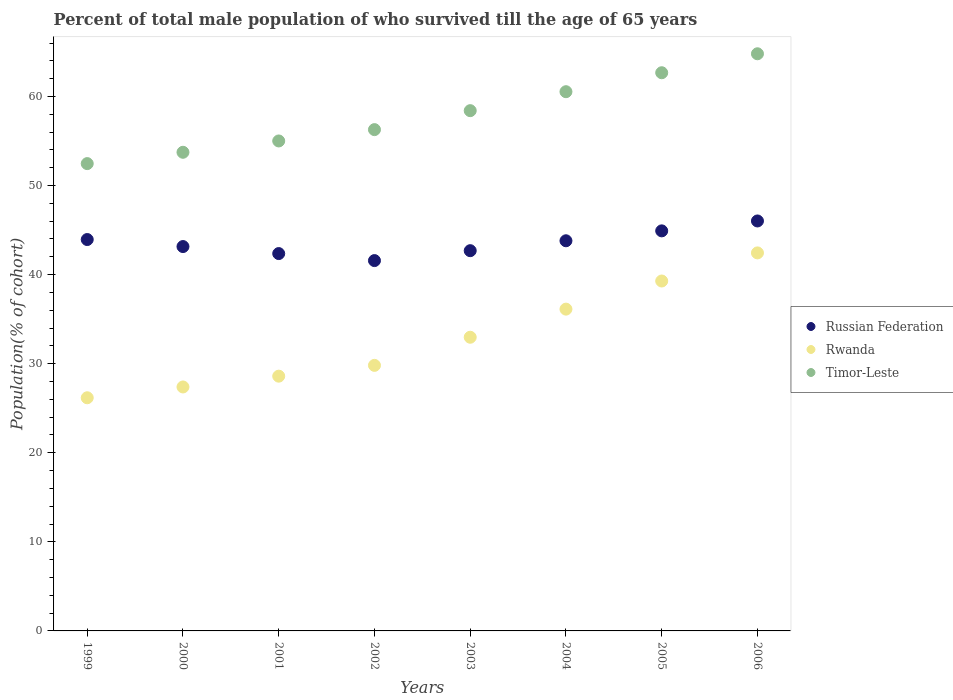What is the percentage of total male population who survived till the age of 65 years in Timor-Leste in 2003?
Your response must be concise. 58.41. Across all years, what is the maximum percentage of total male population who survived till the age of 65 years in Rwanda?
Your answer should be very brief. 42.44. Across all years, what is the minimum percentage of total male population who survived till the age of 65 years in Russian Federation?
Keep it short and to the point. 41.57. In which year was the percentage of total male population who survived till the age of 65 years in Russian Federation maximum?
Offer a terse response. 2006. What is the total percentage of total male population who survived till the age of 65 years in Rwanda in the graph?
Offer a terse response. 262.79. What is the difference between the percentage of total male population who survived till the age of 65 years in Russian Federation in 2005 and that in 2006?
Give a very brief answer. -1.11. What is the difference between the percentage of total male population who survived till the age of 65 years in Russian Federation in 2005 and the percentage of total male population who survived till the age of 65 years in Timor-Leste in 2000?
Provide a succinct answer. -8.82. What is the average percentage of total male population who survived till the age of 65 years in Russian Federation per year?
Keep it short and to the point. 43.56. In the year 2006, what is the difference between the percentage of total male population who survived till the age of 65 years in Rwanda and percentage of total male population who survived till the age of 65 years in Russian Federation?
Make the answer very short. -3.58. In how many years, is the percentage of total male population who survived till the age of 65 years in Russian Federation greater than 48 %?
Make the answer very short. 0. What is the ratio of the percentage of total male population who survived till the age of 65 years in Rwanda in 2000 to that in 2006?
Your answer should be compact. 0.65. Is the percentage of total male population who survived till the age of 65 years in Rwanda in 2000 less than that in 2004?
Your answer should be compact. Yes. What is the difference between the highest and the second highest percentage of total male population who survived till the age of 65 years in Russian Federation?
Provide a short and direct response. 1.11. What is the difference between the highest and the lowest percentage of total male population who survived till the age of 65 years in Timor-Leste?
Your response must be concise. 12.33. Is the sum of the percentage of total male population who survived till the age of 65 years in Russian Federation in 1999 and 2000 greater than the maximum percentage of total male population who survived till the age of 65 years in Rwanda across all years?
Provide a short and direct response. Yes. Is it the case that in every year, the sum of the percentage of total male population who survived till the age of 65 years in Rwanda and percentage of total male population who survived till the age of 65 years in Russian Federation  is greater than the percentage of total male population who survived till the age of 65 years in Timor-Leste?
Ensure brevity in your answer.  Yes. Does the percentage of total male population who survived till the age of 65 years in Rwanda monotonically increase over the years?
Your response must be concise. Yes. How many dotlines are there?
Provide a short and direct response. 3. How many years are there in the graph?
Provide a short and direct response. 8. What is the difference between two consecutive major ticks on the Y-axis?
Your answer should be compact. 10. Does the graph contain any zero values?
Offer a terse response. No. Does the graph contain grids?
Offer a very short reply. No. Where does the legend appear in the graph?
Ensure brevity in your answer.  Center right. How are the legend labels stacked?
Make the answer very short. Vertical. What is the title of the graph?
Make the answer very short. Percent of total male population of who survived till the age of 65 years. What is the label or title of the Y-axis?
Give a very brief answer. Population(% of cohort). What is the Population(% of cohort) of Russian Federation in 1999?
Your answer should be very brief. 43.94. What is the Population(% of cohort) of Rwanda in 1999?
Offer a terse response. 26.17. What is the Population(% of cohort) in Timor-Leste in 1999?
Your response must be concise. 52.46. What is the Population(% of cohort) in Russian Federation in 2000?
Provide a succinct answer. 43.15. What is the Population(% of cohort) in Rwanda in 2000?
Your response must be concise. 27.39. What is the Population(% of cohort) of Timor-Leste in 2000?
Ensure brevity in your answer.  53.73. What is the Population(% of cohort) of Russian Federation in 2001?
Provide a short and direct response. 42.36. What is the Population(% of cohort) in Rwanda in 2001?
Provide a succinct answer. 28.6. What is the Population(% of cohort) in Timor-Leste in 2001?
Make the answer very short. 55.01. What is the Population(% of cohort) of Russian Federation in 2002?
Your response must be concise. 41.57. What is the Population(% of cohort) in Rwanda in 2002?
Keep it short and to the point. 29.81. What is the Population(% of cohort) in Timor-Leste in 2002?
Keep it short and to the point. 56.28. What is the Population(% of cohort) of Russian Federation in 2003?
Your response must be concise. 42.69. What is the Population(% of cohort) in Rwanda in 2003?
Your response must be concise. 32.97. What is the Population(% of cohort) in Timor-Leste in 2003?
Your response must be concise. 58.41. What is the Population(% of cohort) of Russian Federation in 2004?
Offer a terse response. 43.8. What is the Population(% of cohort) of Rwanda in 2004?
Your answer should be very brief. 36.13. What is the Population(% of cohort) of Timor-Leste in 2004?
Your answer should be very brief. 60.53. What is the Population(% of cohort) of Russian Federation in 2005?
Offer a very short reply. 44.91. What is the Population(% of cohort) of Rwanda in 2005?
Provide a short and direct response. 39.28. What is the Population(% of cohort) of Timor-Leste in 2005?
Ensure brevity in your answer.  62.66. What is the Population(% of cohort) of Russian Federation in 2006?
Offer a very short reply. 46.02. What is the Population(% of cohort) in Rwanda in 2006?
Your answer should be very brief. 42.44. What is the Population(% of cohort) in Timor-Leste in 2006?
Provide a short and direct response. 64.79. Across all years, what is the maximum Population(% of cohort) in Russian Federation?
Ensure brevity in your answer.  46.02. Across all years, what is the maximum Population(% of cohort) in Rwanda?
Make the answer very short. 42.44. Across all years, what is the maximum Population(% of cohort) of Timor-Leste?
Your answer should be very brief. 64.79. Across all years, what is the minimum Population(% of cohort) of Russian Federation?
Your answer should be compact. 41.57. Across all years, what is the minimum Population(% of cohort) in Rwanda?
Your answer should be compact. 26.17. Across all years, what is the minimum Population(% of cohort) of Timor-Leste?
Provide a short and direct response. 52.46. What is the total Population(% of cohort) in Russian Federation in the graph?
Your response must be concise. 348.45. What is the total Population(% of cohort) in Rwanda in the graph?
Make the answer very short. 262.79. What is the total Population(% of cohort) in Timor-Leste in the graph?
Your response must be concise. 463.87. What is the difference between the Population(% of cohort) in Russian Federation in 1999 and that in 2000?
Offer a very short reply. 0.79. What is the difference between the Population(% of cohort) in Rwanda in 1999 and that in 2000?
Make the answer very short. -1.21. What is the difference between the Population(% of cohort) in Timor-Leste in 1999 and that in 2000?
Your response must be concise. -1.27. What is the difference between the Population(% of cohort) in Russian Federation in 1999 and that in 2001?
Make the answer very short. 1.58. What is the difference between the Population(% of cohort) of Rwanda in 1999 and that in 2001?
Your answer should be compact. -2.42. What is the difference between the Population(% of cohort) of Timor-Leste in 1999 and that in 2001?
Make the answer very short. -2.54. What is the difference between the Population(% of cohort) in Russian Federation in 1999 and that in 2002?
Your response must be concise. 2.36. What is the difference between the Population(% of cohort) in Rwanda in 1999 and that in 2002?
Offer a very short reply. -3.64. What is the difference between the Population(% of cohort) of Timor-Leste in 1999 and that in 2002?
Offer a very short reply. -3.81. What is the difference between the Population(% of cohort) of Russian Federation in 1999 and that in 2003?
Your answer should be very brief. 1.25. What is the difference between the Population(% of cohort) in Rwanda in 1999 and that in 2003?
Provide a short and direct response. -6.79. What is the difference between the Population(% of cohort) of Timor-Leste in 1999 and that in 2003?
Your response must be concise. -5.94. What is the difference between the Population(% of cohort) in Russian Federation in 1999 and that in 2004?
Give a very brief answer. 0.14. What is the difference between the Population(% of cohort) of Rwanda in 1999 and that in 2004?
Your response must be concise. -9.95. What is the difference between the Population(% of cohort) in Timor-Leste in 1999 and that in 2004?
Make the answer very short. -8.07. What is the difference between the Population(% of cohort) of Russian Federation in 1999 and that in 2005?
Keep it short and to the point. -0.97. What is the difference between the Population(% of cohort) in Rwanda in 1999 and that in 2005?
Your answer should be very brief. -13.11. What is the difference between the Population(% of cohort) in Timor-Leste in 1999 and that in 2005?
Offer a terse response. -10.2. What is the difference between the Population(% of cohort) of Russian Federation in 1999 and that in 2006?
Provide a succinct answer. -2.09. What is the difference between the Population(% of cohort) in Rwanda in 1999 and that in 2006?
Give a very brief answer. -16.26. What is the difference between the Population(% of cohort) in Timor-Leste in 1999 and that in 2006?
Offer a terse response. -12.33. What is the difference between the Population(% of cohort) in Russian Federation in 2000 and that in 2001?
Make the answer very short. 0.79. What is the difference between the Population(% of cohort) in Rwanda in 2000 and that in 2001?
Give a very brief answer. -1.21. What is the difference between the Population(% of cohort) in Timor-Leste in 2000 and that in 2001?
Keep it short and to the point. -1.27. What is the difference between the Population(% of cohort) in Russian Federation in 2000 and that in 2002?
Provide a succinct answer. 1.58. What is the difference between the Population(% of cohort) in Rwanda in 2000 and that in 2002?
Your response must be concise. -2.42. What is the difference between the Population(% of cohort) of Timor-Leste in 2000 and that in 2002?
Provide a succinct answer. -2.54. What is the difference between the Population(% of cohort) in Russian Federation in 2000 and that in 2003?
Offer a terse response. 0.46. What is the difference between the Population(% of cohort) of Rwanda in 2000 and that in 2003?
Make the answer very short. -5.58. What is the difference between the Population(% of cohort) of Timor-Leste in 2000 and that in 2003?
Ensure brevity in your answer.  -4.67. What is the difference between the Population(% of cohort) in Russian Federation in 2000 and that in 2004?
Make the answer very short. -0.65. What is the difference between the Population(% of cohort) in Rwanda in 2000 and that in 2004?
Make the answer very short. -8.74. What is the difference between the Population(% of cohort) of Timor-Leste in 2000 and that in 2004?
Your answer should be compact. -6.8. What is the difference between the Population(% of cohort) in Russian Federation in 2000 and that in 2005?
Provide a short and direct response. -1.76. What is the difference between the Population(% of cohort) in Rwanda in 2000 and that in 2005?
Your response must be concise. -11.9. What is the difference between the Population(% of cohort) in Timor-Leste in 2000 and that in 2005?
Give a very brief answer. -8.93. What is the difference between the Population(% of cohort) of Russian Federation in 2000 and that in 2006?
Offer a terse response. -2.87. What is the difference between the Population(% of cohort) of Rwanda in 2000 and that in 2006?
Your answer should be very brief. -15.05. What is the difference between the Population(% of cohort) of Timor-Leste in 2000 and that in 2006?
Give a very brief answer. -11.06. What is the difference between the Population(% of cohort) in Russian Federation in 2001 and that in 2002?
Provide a short and direct response. 0.79. What is the difference between the Population(% of cohort) in Rwanda in 2001 and that in 2002?
Your answer should be compact. -1.21. What is the difference between the Population(% of cohort) of Timor-Leste in 2001 and that in 2002?
Offer a terse response. -1.27. What is the difference between the Population(% of cohort) in Russian Federation in 2001 and that in 2003?
Provide a succinct answer. -0.32. What is the difference between the Population(% of cohort) in Rwanda in 2001 and that in 2003?
Provide a succinct answer. -4.37. What is the difference between the Population(% of cohort) of Timor-Leste in 2001 and that in 2003?
Give a very brief answer. -3.4. What is the difference between the Population(% of cohort) in Russian Federation in 2001 and that in 2004?
Your answer should be very brief. -1.44. What is the difference between the Population(% of cohort) in Rwanda in 2001 and that in 2004?
Provide a succinct answer. -7.53. What is the difference between the Population(% of cohort) in Timor-Leste in 2001 and that in 2004?
Your answer should be compact. -5.53. What is the difference between the Population(% of cohort) in Russian Federation in 2001 and that in 2005?
Keep it short and to the point. -2.55. What is the difference between the Population(% of cohort) in Rwanda in 2001 and that in 2005?
Make the answer very short. -10.68. What is the difference between the Population(% of cohort) of Timor-Leste in 2001 and that in 2005?
Ensure brevity in your answer.  -7.66. What is the difference between the Population(% of cohort) in Russian Federation in 2001 and that in 2006?
Give a very brief answer. -3.66. What is the difference between the Population(% of cohort) of Rwanda in 2001 and that in 2006?
Offer a very short reply. -13.84. What is the difference between the Population(% of cohort) of Timor-Leste in 2001 and that in 2006?
Give a very brief answer. -9.79. What is the difference between the Population(% of cohort) of Russian Federation in 2002 and that in 2003?
Ensure brevity in your answer.  -1.11. What is the difference between the Population(% of cohort) of Rwanda in 2002 and that in 2003?
Your answer should be very brief. -3.16. What is the difference between the Population(% of cohort) in Timor-Leste in 2002 and that in 2003?
Your response must be concise. -2.13. What is the difference between the Population(% of cohort) in Russian Federation in 2002 and that in 2004?
Give a very brief answer. -2.22. What is the difference between the Population(% of cohort) in Rwanda in 2002 and that in 2004?
Your answer should be very brief. -6.31. What is the difference between the Population(% of cohort) in Timor-Leste in 2002 and that in 2004?
Give a very brief answer. -4.26. What is the difference between the Population(% of cohort) of Russian Federation in 2002 and that in 2005?
Keep it short and to the point. -3.34. What is the difference between the Population(% of cohort) in Rwanda in 2002 and that in 2005?
Provide a succinct answer. -9.47. What is the difference between the Population(% of cohort) of Timor-Leste in 2002 and that in 2005?
Provide a short and direct response. -6.39. What is the difference between the Population(% of cohort) of Russian Federation in 2002 and that in 2006?
Your answer should be very brief. -4.45. What is the difference between the Population(% of cohort) in Rwanda in 2002 and that in 2006?
Keep it short and to the point. -12.63. What is the difference between the Population(% of cohort) of Timor-Leste in 2002 and that in 2006?
Ensure brevity in your answer.  -8.52. What is the difference between the Population(% of cohort) in Russian Federation in 2003 and that in 2004?
Your answer should be very brief. -1.11. What is the difference between the Population(% of cohort) in Rwanda in 2003 and that in 2004?
Offer a terse response. -3.16. What is the difference between the Population(% of cohort) in Timor-Leste in 2003 and that in 2004?
Give a very brief answer. -2.13. What is the difference between the Population(% of cohort) in Russian Federation in 2003 and that in 2005?
Your answer should be very brief. -2.22. What is the difference between the Population(% of cohort) in Rwanda in 2003 and that in 2005?
Provide a short and direct response. -6.31. What is the difference between the Population(% of cohort) in Timor-Leste in 2003 and that in 2005?
Your answer should be very brief. -4.26. What is the difference between the Population(% of cohort) of Russian Federation in 2003 and that in 2006?
Your answer should be very brief. -3.34. What is the difference between the Population(% of cohort) of Rwanda in 2003 and that in 2006?
Make the answer very short. -9.47. What is the difference between the Population(% of cohort) of Timor-Leste in 2003 and that in 2006?
Your answer should be compact. -6.39. What is the difference between the Population(% of cohort) of Russian Federation in 2004 and that in 2005?
Provide a short and direct response. -1.11. What is the difference between the Population(% of cohort) of Rwanda in 2004 and that in 2005?
Give a very brief answer. -3.16. What is the difference between the Population(% of cohort) of Timor-Leste in 2004 and that in 2005?
Your answer should be compact. -2.13. What is the difference between the Population(% of cohort) of Russian Federation in 2004 and that in 2006?
Your response must be concise. -2.22. What is the difference between the Population(% of cohort) of Rwanda in 2004 and that in 2006?
Your response must be concise. -6.31. What is the difference between the Population(% of cohort) of Timor-Leste in 2004 and that in 2006?
Provide a short and direct response. -4.26. What is the difference between the Population(% of cohort) in Russian Federation in 2005 and that in 2006?
Keep it short and to the point. -1.11. What is the difference between the Population(% of cohort) of Rwanda in 2005 and that in 2006?
Ensure brevity in your answer.  -3.16. What is the difference between the Population(% of cohort) of Timor-Leste in 2005 and that in 2006?
Offer a terse response. -2.13. What is the difference between the Population(% of cohort) of Russian Federation in 1999 and the Population(% of cohort) of Rwanda in 2000?
Provide a short and direct response. 16.55. What is the difference between the Population(% of cohort) of Russian Federation in 1999 and the Population(% of cohort) of Timor-Leste in 2000?
Your answer should be very brief. -9.8. What is the difference between the Population(% of cohort) of Rwanda in 1999 and the Population(% of cohort) of Timor-Leste in 2000?
Keep it short and to the point. -27.56. What is the difference between the Population(% of cohort) of Russian Federation in 1999 and the Population(% of cohort) of Rwanda in 2001?
Keep it short and to the point. 15.34. What is the difference between the Population(% of cohort) of Russian Federation in 1999 and the Population(% of cohort) of Timor-Leste in 2001?
Your answer should be compact. -11.07. What is the difference between the Population(% of cohort) of Rwanda in 1999 and the Population(% of cohort) of Timor-Leste in 2001?
Your answer should be compact. -28.83. What is the difference between the Population(% of cohort) of Russian Federation in 1999 and the Population(% of cohort) of Rwanda in 2002?
Your answer should be compact. 14.13. What is the difference between the Population(% of cohort) of Russian Federation in 1999 and the Population(% of cohort) of Timor-Leste in 2002?
Provide a short and direct response. -12.34. What is the difference between the Population(% of cohort) of Rwanda in 1999 and the Population(% of cohort) of Timor-Leste in 2002?
Offer a very short reply. -30.1. What is the difference between the Population(% of cohort) in Russian Federation in 1999 and the Population(% of cohort) in Rwanda in 2003?
Your answer should be very brief. 10.97. What is the difference between the Population(% of cohort) in Russian Federation in 1999 and the Population(% of cohort) in Timor-Leste in 2003?
Provide a short and direct response. -14.47. What is the difference between the Population(% of cohort) of Rwanda in 1999 and the Population(% of cohort) of Timor-Leste in 2003?
Offer a terse response. -32.23. What is the difference between the Population(% of cohort) in Russian Federation in 1999 and the Population(% of cohort) in Rwanda in 2004?
Make the answer very short. 7.81. What is the difference between the Population(% of cohort) of Russian Federation in 1999 and the Population(% of cohort) of Timor-Leste in 2004?
Your answer should be compact. -16.6. What is the difference between the Population(% of cohort) of Rwanda in 1999 and the Population(% of cohort) of Timor-Leste in 2004?
Offer a terse response. -34.36. What is the difference between the Population(% of cohort) in Russian Federation in 1999 and the Population(% of cohort) in Rwanda in 2005?
Provide a short and direct response. 4.66. What is the difference between the Population(% of cohort) in Russian Federation in 1999 and the Population(% of cohort) in Timor-Leste in 2005?
Offer a very short reply. -18.73. What is the difference between the Population(% of cohort) of Rwanda in 1999 and the Population(% of cohort) of Timor-Leste in 2005?
Ensure brevity in your answer.  -36.49. What is the difference between the Population(% of cohort) in Russian Federation in 1999 and the Population(% of cohort) in Rwanda in 2006?
Make the answer very short. 1.5. What is the difference between the Population(% of cohort) of Russian Federation in 1999 and the Population(% of cohort) of Timor-Leste in 2006?
Offer a very short reply. -20.85. What is the difference between the Population(% of cohort) in Rwanda in 1999 and the Population(% of cohort) in Timor-Leste in 2006?
Provide a short and direct response. -38.62. What is the difference between the Population(% of cohort) in Russian Federation in 2000 and the Population(% of cohort) in Rwanda in 2001?
Offer a terse response. 14.55. What is the difference between the Population(% of cohort) in Russian Federation in 2000 and the Population(% of cohort) in Timor-Leste in 2001?
Give a very brief answer. -11.86. What is the difference between the Population(% of cohort) of Rwanda in 2000 and the Population(% of cohort) of Timor-Leste in 2001?
Your answer should be very brief. -27.62. What is the difference between the Population(% of cohort) in Russian Federation in 2000 and the Population(% of cohort) in Rwanda in 2002?
Provide a succinct answer. 13.34. What is the difference between the Population(% of cohort) in Russian Federation in 2000 and the Population(% of cohort) in Timor-Leste in 2002?
Your response must be concise. -13.13. What is the difference between the Population(% of cohort) in Rwanda in 2000 and the Population(% of cohort) in Timor-Leste in 2002?
Provide a short and direct response. -28.89. What is the difference between the Population(% of cohort) of Russian Federation in 2000 and the Population(% of cohort) of Rwanda in 2003?
Keep it short and to the point. 10.18. What is the difference between the Population(% of cohort) in Russian Federation in 2000 and the Population(% of cohort) in Timor-Leste in 2003?
Your answer should be compact. -15.26. What is the difference between the Population(% of cohort) in Rwanda in 2000 and the Population(% of cohort) in Timor-Leste in 2003?
Your answer should be very brief. -31.02. What is the difference between the Population(% of cohort) in Russian Federation in 2000 and the Population(% of cohort) in Rwanda in 2004?
Give a very brief answer. 7.02. What is the difference between the Population(% of cohort) of Russian Federation in 2000 and the Population(% of cohort) of Timor-Leste in 2004?
Your answer should be very brief. -17.38. What is the difference between the Population(% of cohort) of Rwanda in 2000 and the Population(% of cohort) of Timor-Leste in 2004?
Offer a terse response. -33.15. What is the difference between the Population(% of cohort) in Russian Federation in 2000 and the Population(% of cohort) in Rwanda in 2005?
Make the answer very short. 3.87. What is the difference between the Population(% of cohort) of Russian Federation in 2000 and the Population(% of cohort) of Timor-Leste in 2005?
Offer a terse response. -19.51. What is the difference between the Population(% of cohort) of Rwanda in 2000 and the Population(% of cohort) of Timor-Leste in 2005?
Give a very brief answer. -35.28. What is the difference between the Population(% of cohort) of Russian Federation in 2000 and the Population(% of cohort) of Rwanda in 2006?
Keep it short and to the point. 0.71. What is the difference between the Population(% of cohort) in Russian Federation in 2000 and the Population(% of cohort) in Timor-Leste in 2006?
Your answer should be compact. -21.64. What is the difference between the Population(% of cohort) in Rwanda in 2000 and the Population(% of cohort) in Timor-Leste in 2006?
Your answer should be very brief. -37.41. What is the difference between the Population(% of cohort) of Russian Federation in 2001 and the Population(% of cohort) of Rwanda in 2002?
Your answer should be compact. 12.55. What is the difference between the Population(% of cohort) of Russian Federation in 2001 and the Population(% of cohort) of Timor-Leste in 2002?
Your response must be concise. -13.91. What is the difference between the Population(% of cohort) of Rwanda in 2001 and the Population(% of cohort) of Timor-Leste in 2002?
Keep it short and to the point. -27.68. What is the difference between the Population(% of cohort) of Russian Federation in 2001 and the Population(% of cohort) of Rwanda in 2003?
Your answer should be compact. 9.39. What is the difference between the Population(% of cohort) in Russian Federation in 2001 and the Population(% of cohort) in Timor-Leste in 2003?
Keep it short and to the point. -16.04. What is the difference between the Population(% of cohort) of Rwanda in 2001 and the Population(% of cohort) of Timor-Leste in 2003?
Your answer should be very brief. -29.81. What is the difference between the Population(% of cohort) of Russian Federation in 2001 and the Population(% of cohort) of Rwanda in 2004?
Ensure brevity in your answer.  6.24. What is the difference between the Population(% of cohort) of Russian Federation in 2001 and the Population(% of cohort) of Timor-Leste in 2004?
Provide a short and direct response. -18.17. What is the difference between the Population(% of cohort) in Rwanda in 2001 and the Population(% of cohort) in Timor-Leste in 2004?
Give a very brief answer. -31.94. What is the difference between the Population(% of cohort) in Russian Federation in 2001 and the Population(% of cohort) in Rwanda in 2005?
Provide a succinct answer. 3.08. What is the difference between the Population(% of cohort) in Russian Federation in 2001 and the Population(% of cohort) in Timor-Leste in 2005?
Ensure brevity in your answer.  -20.3. What is the difference between the Population(% of cohort) of Rwanda in 2001 and the Population(% of cohort) of Timor-Leste in 2005?
Your answer should be very brief. -34.06. What is the difference between the Population(% of cohort) of Russian Federation in 2001 and the Population(% of cohort) of Rwanda in 2006?
Provide a succinct answer. -0.08. What is the difference between the Population(% of cohort) in Russian Federation in 2001 and the Population(% of cohort) in Timor-Leste in 2006?
Your answer should be compact. -22.43. What is the difference between the Population(% of cohort) of Rwanda in 2001 and the Population(% of cohort) of Timor-Leste in 2006?
Your answer should be compact. -36.19. What is the difference between the Population(% of cohort) in Russian Federation in 2002 and the Population(% of cohort) in Rwanda in 2003?
Keep it short and to the point. 8.61. What is the difference between the Population(% of cohort) of Russian Federation in 2002 and the Population(% of cohort) of Timor-Leste in 2003?
Your response must be concise. -16.83. What is the difference between the Population(% of cohort) in Rwanda in 2002 and the Population(% of cohort) in Timor-Leste in 2003?
Keep it short and to the point. -28.59. What is the difference between the Population(% of cohort) of Russian Federation in 2002 and the Population(% of cohort) of Rwanda in 2004?
Your response must be concise. 5.45. What is the difference between the Population(% of cohort) in Russian Federation in 2002 and the Population(% of cohort) in Timor-Leste in 2004?
Offer a very short reply. -18.96. What is the difference between the Population(% of cohort) in Rwanda in 2002 and the Population(% of cohort) in Timor-Leste in 2004?
Make the answer very short. -30.72. What is the difference between the Population(% of cohort) in Russian Federation in 2002 and the Population(% of cohort) in Rwanda in 2005?
Make the answer very short. 2.29. What is the difference between the Population(% of cohort) in Russian Federation in 2002 and the Population(% of cohort) in Timor-Leste in 2005?
Your response must be concise. -21.09. What is the difference between the Population(% of cohort) of Rwanda in 2002 and the Population(% of cohort) of Timor-Leste in 2005?
Provide a short and direct response. -32.85. What is the difference between the Population(% of cohort) in Russian Federation in 2002 and the Population(% of cohort) in Rwanda in 2006?
Offer a terse response. -0.86. What is the difference between the Population(% of cohort) in Russian Federation in 2002 and the Population(% of cohort) in Timor-Leste in 2006?
Your answer should be very brief. -23.22. What is the difference between the Population(% of cohort) in Rwanda in 2002 and the Population(% of cohort) in Timor-Leste in 2006?
Make the answer very short. -34.98. What is the difference between the Population(% of cohort) in Russian Federation in 2003 and the Population(% of cohort) in Rwanda in 2004?
Your response must be concise. 6.56. What is the difference between the Population(% of cohort) in Russian Federation in 2003 and the Population(% of cohort) in Timor-Leste in 2004?
Give a very brief answer. -17.85. What is the difference between the Population(% of cohort) in Rwanda in 2003 and the Population(% of cohort) in Timor-Leste in 2004?
Provide a succinct answer. -27.57. What is the difference between the Population(% of cohort) of Russian Federation in 2003 and the Population(% of cohort) of Rwanda in 2005?
Provide a succinct answer. 3.4. What is the difference between the Population(% of cohort) in Russian Federation in 2003 and the Population(% of cohort) in Timor-Leste in 2005?
Keep it short and to the point. -19.98. What is the difference between the Population(% of cohort) in Rwanda in 2003 and the Population(% of cohort) in Timor-Leste in 2005?
Provide a succinct answer. -29.7. What is the difference between the Population(% of cohort) of Russian Federation in 2003 and the Population(% of cohort) of Rwanda in 2006?
Your answer should be very brief. 0.25. What is the difference between the Population(% of cohort) in Russian Federation in 2003 and the Population(% of cohort) in Timor-Leste in 2006?
Provide a short and direct response. -22.11. What is the difference between the Population(% of cohort) in Rwanda in 2003 and the Population(% of cohort) in Timor-Leste in 2006?
Your answer should be very brief. -31.82. What is the difference between the Population(% of cohort) in Russian Federation in 2004 and the Population(% of cohort) in Rwanda in 2005?
Make the answer very short. 4.52. What is the difference between the Population(% of cohort) of Russian Federation in 2004 and the Population(% of cohort) of Timor-Leste in 2005?
Your response must be concise. -18.86. What is the difference between the Population(% of cohort) of Rwanda in 2004 and the Population(% of cohort) of Timor-Leste in 2005?
Make the answer very short. -26.54. What is the difference between the Population(% of cohort) in Russian Federation in 2004 and the Population(% of cohort) in Rwanda in 2006?
Keep it short and to the point. 1.36. What is the difference between the Population(% of cohort) of Russian Federation in 2004 and the Population(% of cohort) of Timor-Leste in 2006?
Provide a succinct answer. -20.99. What is the difference between the Population(% of cohort) of Rwanda in 2004 and the Population(% of cohort) of Timor-Leste in 2006?
Your answer should be very brief. -28.67. What is the difference between the Population(% of cohort) of Russian Federation in 2005 and the Population(% of cohort) of Rwanda in 2006?
Provide a succinct answer. 2.47. What is the difference between the Population(% of cohort) in Russian Federation in 2005 and the Population(% of cohort) in Timor-Leste in 2006?
Ensure brevity in your answer.  -19.88. What is the difference between the Population(% of cohort) in Rwanda in 2005 and the Population(% of cohort) in Timor-Leste in 2006?
Keep it short and to the point. -25.51. What is the average Population(% of cohort) of Russian Federation per year?
Offer a terse response. 43.56. What is the average Population(% of cohort) of Rwanda per year?
Offer a terse response. 32.85. What is the average Population(% of cohort) in Timor-Leste per year?
Your answer should be compact. 57.98. In the year 1999, what is the difference between the Population(% of cohort) of Russian Federation and Population(% of cohort) of Rwanda?
Ensure brevity in your answer.  17.76. In the year 1999, what is the difference between the Population(% of cohort) of Russian Federation and Population(% of cohort) of Timor-Leste?
Your response must be concise. -8.52. In the year 1999, what is the difference between the Population(% of cohort) of Rwanda and Population(% of cohort) of Timor-Leste?
Provide a succinct answer. -26.29. In the year 2000, what is the difference between the Population(% of cohort) in Russian Federation and Population(% of cohort) in Rwanda?
Keep it short and to the point. 15.76. In the year 2000, what is the difference between the Population(% of cohort) of Russian Federation and Population(% of cohort) of Timor-Leste?
Your answer should be compact. -10.58. In the year 2000, what is the difference between the Population(% of cohort) in Rwanda and Population(% of cohort) in Timor-Leste?
Offer a terse response. -26.35. In the year 2001, what is the difference between the Population(% of cohort) in Russian Federation and Population(% of cohort) in Rwanda?
Provide a succinct answer. 13.76. In the year 2001, what is the difference between the Population(% of cohort) of Russian Federation and Population(% of cohort) of Timor-Leste?
Offer a very short reply. -12.64. In the year 2001, what is the difference between the Population(% of cohort) of Rwanda and Population(% of cohort) of Timor-Leste?
Keep it short and to the point. -26.41. In the year 2002, what is the difference between the Population(% of cohort) of Russian Federation and Population(% of cohort) of Rwanda?
Ensure brevity in your answer.  11.76. In the year 2002, what is the difference between the Population(% of cohort) in Russian Federation and Population(% of cohort) in Timor-Leste?
Keep it short and to the point. -14.7. In the year 2002, what is the difference between the Population(% of cohort) in Rwanda and Population(% of cohort) in Timor-Leste?
Your answer should be compact. -26.47. In the year 2003, what is the difference between the Population(% of cohort) in Russian Federation and Population(% of cohort) in Rwanda?
Make the answer very short. 9.72. In the year 2003, what is the difference between the Population(% of cohort) of Russian Federation and Population(% of cohort) of Timor-Leste?
Offer a terse response. -15.72. In the year 2003, what is the difference between the Population(% of cohort) of Rwanda and Population(% of cohort) of Timor-Leste?
Provide a succinct answer. -25.44. In the year 2004, what is the difference between the Population(% of cohort) of Russian Federation and Population(% of cohort) of Rwanda?
Give a very brief answer. 7.67. In the year 2004, what is the difference between the Population(% of cohort) in Russian Federation and Population(% of cohort) in Timor-Leste?
Give a very brief answer. -16.74. In the year 2004, what is the difference between the Population(% of cohort) in Rwanda and Population(% of cohort) in Timor-Leste?
Provide a short and direct response. -24.41. In the year 2005, what is the difference between the Population(% of cohort) in Russian Federation and Population(% of cohort) in Rwanda?
Make the answer very short. 5.63. In the year 2005, what is the difference between the Population(% of cohort) in Russian Federation and Population(% of cohort) in Timor-Leste?
Offer a very short reply. -17.75. In the year 2005, what is the difference between the Population(% of cohort) of Rwanda and Population(% of cohort) of Timor-Leste?
Your answer should be very brief. -23.38. In the year 2006, what is the difference between the Population(% of cohort) in Russian Federation and Population(% of cohort) in Rwanda?
Provide a short and direct response. 3.58. In the year 2006, what is the difference between the Population(% of cohort) of Russian Federation and Population(% of cohort) of Timor-Leste?
Your response must be concise. -18.77. In the year 2006, what is the difference between the Population(% of cohort) in Rwanda and Population(% of cohort) in Timor-Leste?
Ensure brevity in your answer.  -22.35. What is the ratio of the Population(% of cohort) in Russian Federation in 1999 to that in 2000?
Provide a succinct answer. 1.02. What is the ratio of the Population(% of cohort) in Rwanda in 1999 to that in 2000?
Provide a short and direct response. 0.96. What is the ratio of the Population(% of cohort) of Timor-Leste in 1999 to that in 2000?
Provide a short and direct response. 0.98. What is the ratio of the Population(% of cohort) in Russian Federation in 1999 to that in 2001?
Your answer should be compact. 1.04. What is the ratio of the Population(% of cohort) in Rwanda in 1999 to that in 2001?
Give a very brief answer. 0.92. What is the ratio of the Population(% of cohort) in Timor-Leste in 1999 to that in 2001?
Your response must be concise. 0.95. What is the ratio of the Population(% of cohort) of Russian Federation in 1999 to that in 2002?
Make the answer very short. 1.06. What is the ratio of the Population(% of cohort) in Rwanda in 1999 to that in 2002?
Give a very brief answer. 0.88. What is the ratio of the Population(% of cohort) of Timor-Leste in 1999 to that in 2002?
Make the answer very short. 0.93. What is the ratio of the Population(% of cohort) of Russian Federation in 1999 to that in 2003?
Your response must be concise. 1.03. What is the ratio of the Population(% of cohort) in Rwanda in 1999 to that in 2003?
Your answer should be compact. 0.79. What is the ratio of the Population(% of cohort) of Timor-Leste in 1999 to that in 2003?
Ensure brevity in your answer.  0.9. What is the ratio of the Population(% of cohort) in Rwanda in 1999 to that in 2004?
Provide a succinct answer. 0.72. What is the ratio of the Population(% of cohort) of Timor-Leste in 1999 to that in 2004?
Keep it short and to the point. 0.87. What is the ratio of the Population(% of cohort) in Russian Federation in 1999 to that in 2005?
Give a very brief answer. 0.98. What is the ratio of the Population(% of cohort) in Rwanda in 1999 to that in 2005?
Provide a succinct answer. 0.67. What is the ratio of the Population(% of cohort) of Timor-Leste in 1999 to that in 2005?
Provide a succinct answer. 0.84. What is the ratio of the Population(% of cohort) in Russian Federation in 1999 to that in 2006?
Make the answer very short. 0.95. What is the ratio of the Population(% of cohort) of Rwanda in 1999 to that in 2006?
Offer a terse response. 0.62. What is the ratio of the Population(% of cohort) in Timor-Leste in 1999 to that in 2006?
Offer a terse response. 0.81. What is the ratio of the Population(% of cohort) in Russian Federation in 2000 to that in 2001?
Give a very brief answer. 1.02. What is the ratio of the Population(% of cohort) of Rwanda in 2000 to that in 2001?
Ensure brevity in your answer.  0.96. What is the ratio of the Population(% of cohort) in Timor-Leste in 2000 to that in 2001?
Offer a terse response. 0.98. What is the ratio of the Population(% of cohort) in Russian Federation in 2000 to that in 2002?
Ensure brevity in your answer.  1.04. What is the ratio of the Population(% of cohort) of Rwanda in 2000 to that in 2002?
Provide a short and direct response. 0.92. What is the ratio of the Population(% of cohort) of Timor-Leste in 2000 to that in 2002?
Your answer should be very brief. 0.95. What is the ratio of the Population(% of cohort) in Russian Federation in 2000 to that in 2003?
Offer a very short reply. 1.01. What is the ratio of the Population(% of cohort) of Rwanda in 2000 to that in 2003?
Give a very brief answer. 0.83. What is the ratio of the Population(% of cohort) in Timor-Leste in 2000 to that in 2003?
Make the answer very short. 0.92. What is the ratio of the Population(% of cohort) of Russian Federation in 2000 to that in 2004?
Your answer should be compact. 0.99. What is the ratio of the Population(% of cohort) of Rwanda in 2000 to that in 2004?
Ensure brevity in your answer.  0.76. What is the ratio of the Population(% of cohort) of Timor-Leste in 2000 to that in 2004?
Keep it short and to the point. 0.89. What is the ratio of the Population(% of cohort) of Russian Federation in 2000 to that in 2005?
Ensure brevity in your answer.  0.96. What is the ratio of the Population(% of cohort) of Rwanda in 2000 to that in 2005?
Your response must be concise. 0.7. What is the ratio of the Population(% of cohort) in Timor-Leste in 2000 to that in 2005?
Your answer should be compact. 0.86. What is the ratio of the Population(% of cohort) in Russian Federation in 2000 to that in 2006?
Make the answer very short. 0.94. What is the ratio of the Population(% of cohort) of Rwanda in 2000 to that in 2006?
Keep it short and to the point. 0.65. What is the ratio of the Population(% of cohort) of Timor-Leste in 2000 to that in 2006?
Your answer should be very brief. 0.83. What is the ratio of the Population(% of cohort) of Russian Federation in 2001 to that in 2002?
Offer a terse response. 1.02. What is the ratio of the Population(% of cohort) in Rwanda in 2001 to that in 2002?
Make the answer very short. 0.96. What is the ratio of the Population(% of cohort) in Timor-Leste in 2001 to that in 2002?
Give a very brief answer. 0.98. What is the ratio of the Population(% of cohort) of Rwanda in 2001 to that in 2003?
Offer a very short reply. 0.87. What is the ratio of the Population(% of cohort) of Timor-Leste in 2001 to that in 2003?
Your answer should be compact. 0.94. What is the ratio of the Population(% of cohort) of Russian Federation in 2001 to that in 2004?
Provide a succinct answer. 0.97. What is the ratio of the Population(% of cohort) of Rwanda in 2001 to that in 2004?
Provide a succinct answer. 0.79. What is the ratio of the Population(% of cohort) of Timor-Leste in 2001 to that in 2004?
Your response must be concise. 0.91. What is the ratio of the Population(% of cohort) of Russian Federation in 2001 to that in 2005?
Your response must be concise. 0.94. What is the ratio of the Population(% of cohort) in Rwanda in 2001 to that in 2005?
Your answer should be compact. 0.73. What is the ratio of the Population(% of cohort) of Timor-Leste in 2001 to that in 2005?
Offer a terse response. 0.88. What is the ratio of the Population(% of cohort) of Russian Federation in 2001 to that in 2006?
Provide a short and direct response. 0.92. What is the ratio of the Population(% of cohort) in Rwanda in 2001 to that in 2006?
Make the answer very short. 0.67. What is the ratio of the Population(% of cohort) in Timor-Leste in 2001 to that in 2006?
Keep it short and to the point. 0.85. What is the ratio of the Population(% of cohort) in Russian Federation in 2002 to that in 2003?
Provide a short and direct response. 0.97. What is the ratio of the Population(% of cohort) of Rwanda in 2002 to that in 2003?
Provide a short and direct response. 0.9. What is the ratio of the Population(% of cohort) in Timor-Leste in 2002 to that in 2003?
Make the answer very short. 0.96. What is the ratio of the Population(% of cohort) in Russian Federation in 2002 to that in 2004?
Offer a very short reply. 0.95. What is the ratio of the Population(% of cohort) in Rwanda in 2002 to that in 2004?
Provide a succinct answer. 0.83. What is the ratio of the Population(% of cohort) of Timor-Leste in 2002 to that in 2004?
Your answer should be very brief. 0.93. What is the ratio of the Population(% of cohort) in Russian Federation in 2002 to that in 2005?
Keep it short and to the point. 0.93. What is the ratio of the Population(% of cohort) in Rwanda in 2002 to that in 2005?
Give a very brief answer. 0.76. What is the ratio of the Population(% of cohort) of Timor-Leste in 2002 to that in 2005?
Ensure brevity in your answer.  0.9. What is the ratio of the Population(% of cohort) in Russian Federation in 2002 to that in 2006?
Your response must be concise. 0.9. What is the ratio of the Population(% of cohort) in Rwanda in 2002 to that in 2006?
Offer a terse response. 0.7. What is the ratio of the Population(% of cohort) of Timor-Leste in 2002 to that in 2006?
Ensure brevity in your answer.  0.87. What is the ratio of the Population(% of cohort) of Russian Federation in 2003 to that in 2004?
Your answer should be compact. 0.97. What is the ratio of the Population(% of cohort) of Rwanda in 2003 to that in 2004?
Make the answer very short. 0.91. What is the ratio of the Population(% of cohort) in Timor-Leste in 2003 to that in 2004?
Your answer should be compact. 0.96. What is the ratio of the Population(% of cohort) in Russian Federation in 2003 to that in 2005?
Make the answer very short. 0.95. What is the ratio of the Population(% of cohort) of Rwanda in 2003 to that in 2005?
Provide a succinct answer. 0.84. What is the ratio of the Population(% of cohort) in Timor-Leste in 2003 to that in 2005?
Provide a succinct answer. 0.93. What is the ratio of the Population(% of cohort) of Russian Federation in 2003 to that in 2006?
Provide a short and direct response. 0.93. What is the ratio of the Population(% of cohort) in Rwanda in 2003 to that in 2006?
Your answer should be compact. 0.78. What is the ratio of the Population(% of cohort) in Timor-Leste in 2003 to that in 2006?
Offer a terse response. 0.9. What is the ratio of the Population(% of cohort) in Russian Federation in 2004 to that in 2005?
Offer a terse response. 0.98. What is the ratio of the Population(% of cohort) of Rwanda in 2004 to that in 2005?
Offer a terse response. 0.92. What is the ratio of the Population(% of cohort) of Timor-Leste in 2004 to that in 2005?
Your response must be concise. 0.97. What is the ratio of the Population(% of cohort) in Russian Federation in 2004 to that in 2006?
Ensure brevity in your answer.  0.95. What is the ratio of the Population(% of cohort) in Rwanda in 2004 to that in 2006?
Offer a very short reply. 0.85. What is the ratio of the Population(% of cohort) in Timor-Leste in 2004 to that in 2006?
Provide a short and direct response. 0.93. What is the ratio of the Population(% of cohort) of Russian Federation in 2005 to that in 2006?
Give a very brief answer. 0.98. What is the ratio of the Population(% of cohort) of Rwanda in 2005 to that in 2006?
Offer a terse response. 0.93. What is the ratio of the Population(% of cohort) of Timor-Leste in 2005 to that in 2006?
Give a very brief answer. 0.97. What is the difference between the highest and the second highest Population(% of cohort) in Russian Federation?
Your answer should be compact. 1.11. What is the difference between the highest and the second highest Population(% of cohort) in Rwanda?
Make the answer very short. 3.16. What is the difference between the highest and the second highest Population(% of cohort) in Timor-Leste?
Your answer should be very brief. 2.13. What is the difference between the highest and the lowest Population(% of cohort) of Russian Federation?
Offer a very short reply. 4.45. What is the difference between the highest and the lowest Population(% of cohort) of Rwanda?
Your answer should be very brief. 16.26. What is the difference between the highest and the lowest Population(% of cohort) of Timor-Leste?
Give a very brief answer. 12.33. 